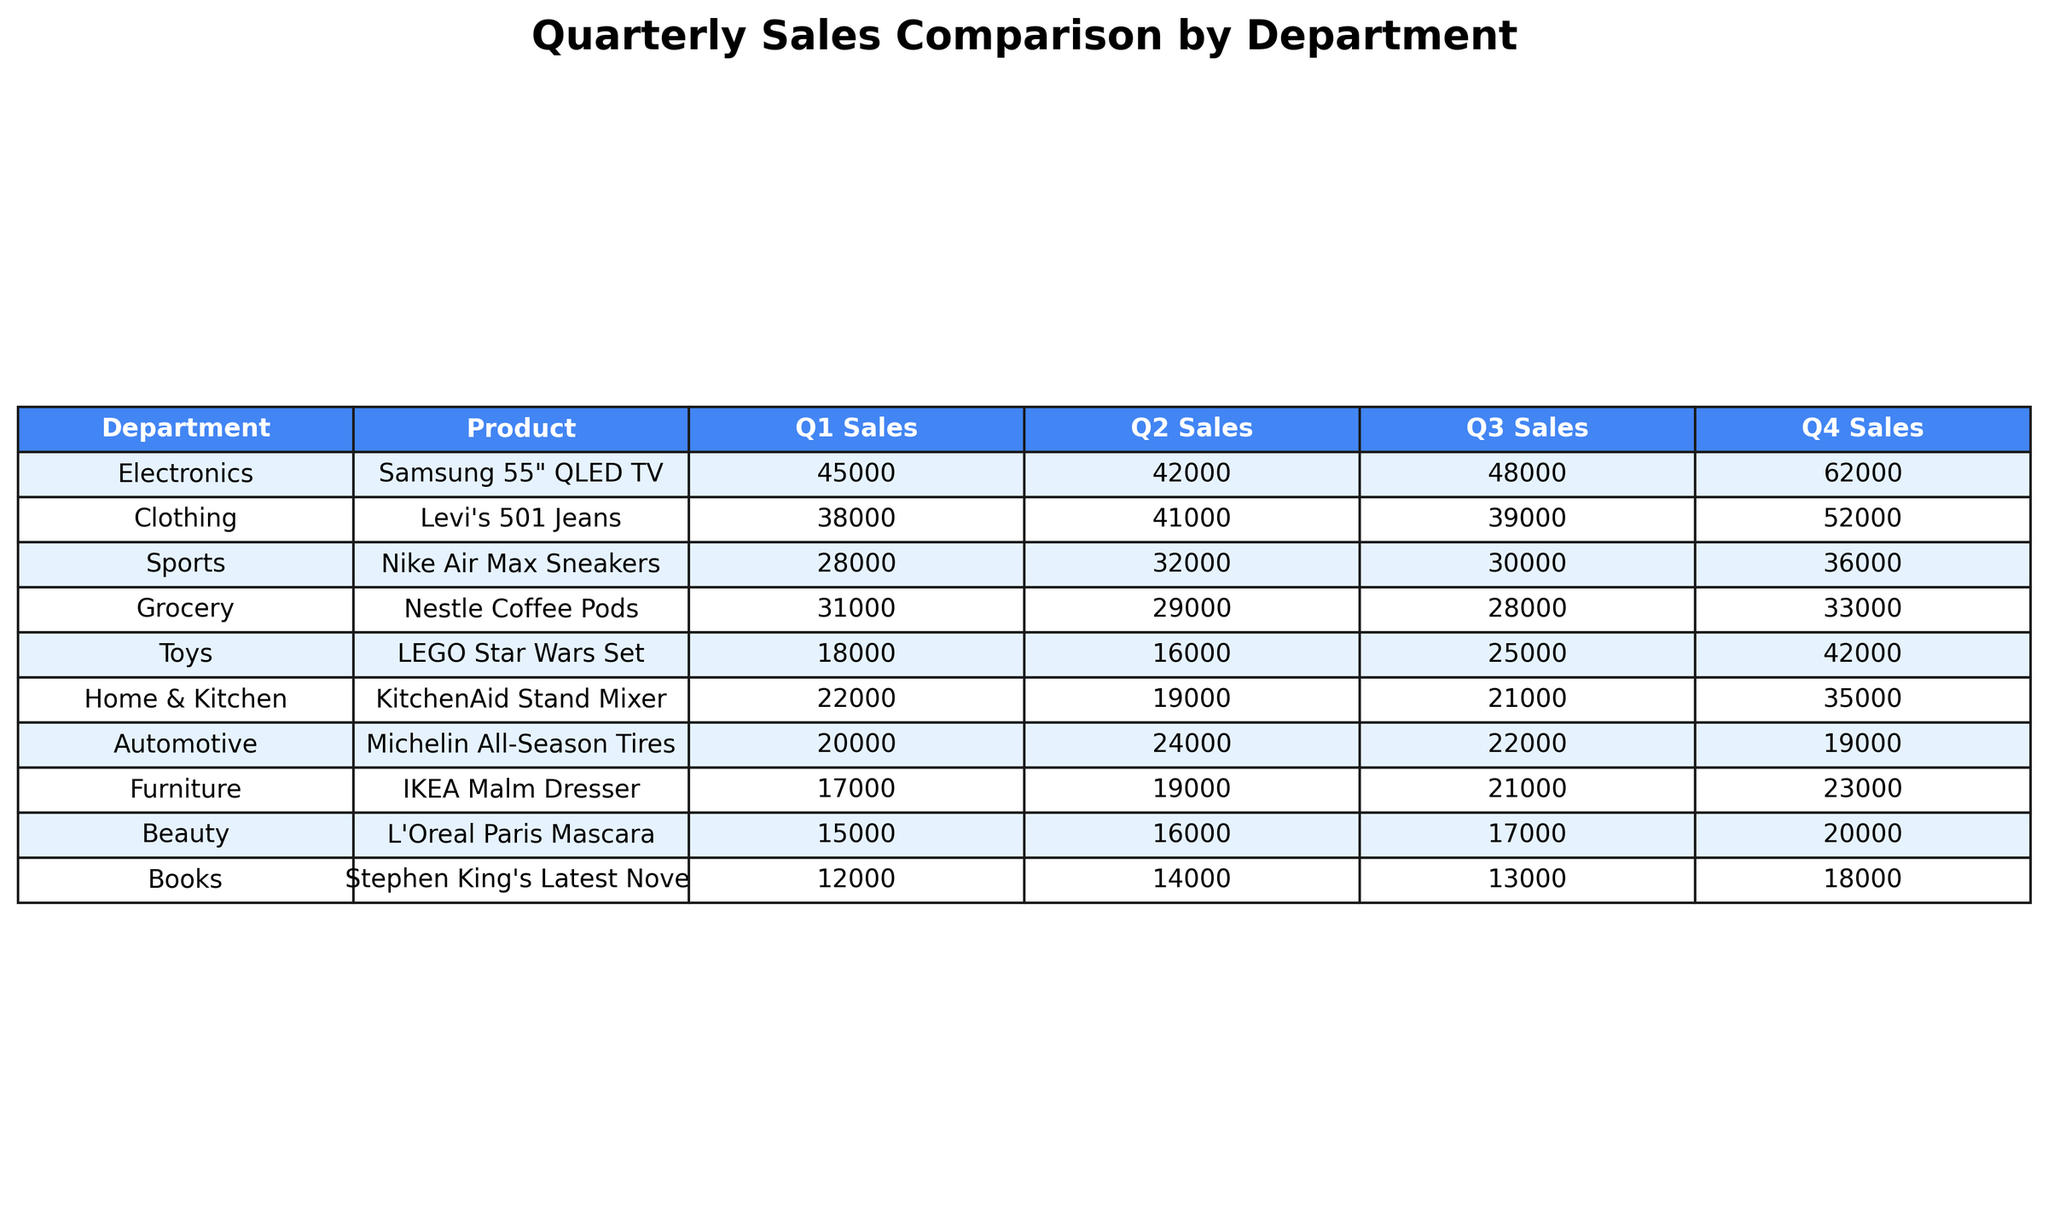What product had the highest sales in Q4? By examining the Q4 sales column, the Samsung 55" QLED TV has the highest sales figure at 62000.
Answer: Samsung 55" QLED TV What was the total sales for KitchenAid Stand Mixer across all quarters? Summing up the sales for the KitchenAid Stand Mixer: (22000 + 19000 + 21000 + 35000) = 97000.
Answer: 97000 Which department had the lowest Q1 sales? The Beauty department had Q1 sales of 15000, which is the lowest compared to other departments in Q1.
Answer: Beauty What is the average sales of the Nike Air Max Sneakers over the year? The average sales for Nike Air Max Sneakers is calculated as follows: (28000 + 32000 + 30000 + 36000) / 4 = 31500.
Answer: 31500 Did any product have a decrease in sales from Q1 to Q2? Yes, the Samsung 55" QLED TV sales decreased from 45000 in Q1 to 42000 in Q2.
Answer: Yes What is the sales difference between the top-selling product and the second top-selling product in Q4? The top-selling product (Samsung 55" QLED TV) sold 62000 and the second (Levi's 501 Jeans) sold 52000, so the difference is 62000 - 52000 = 10000.
Answer: 10000 Which product consistently saw an increase in sales from Q1 to Q4? The LEGO Star Wars Set showed an increase in sales from 18000 in Q1 to 42000 in Q4.
Answer: LEGO Star Wars Set What was the total sales for the Grocery department across all quarters? For Grocery, the total sales sum is (31000 + 29000 + 28000 + 33000) = 121000.
Answer: 121000 How many products had total sales greater than 100000 throughout the year? Examining total sales, both Samsung 55" QLED TV and Grocery had sales greater than 100000, so there are 2 products.
Answer: 2 In which quarter did the Levi's 501 Jeans have the lowest sales? The sales for Levi's 501 Jeans were lowest in Q3 with 39000, as seen from the quarterly sales columns.
Answer: Q3 